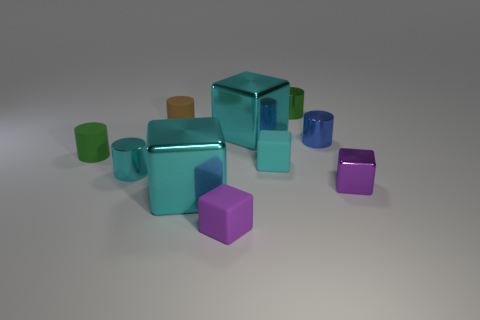Subtract all small rubber blocks. How many blocks are left? 3 Subtract all cyan cylinders. How many cylinders are left? 4 Subtract 4 cylinders. How many cylinders are left? 1 Add 3 small blue metal cylinders. How many small blue metal cylinders are left? 4 Add 8 green matte cylinders. How many green matte cylinders exist? 9 Subtract 0 green spheres. How many objects are left? 10 Subtract all gray cubes. Subtract all brown cylinders. How many cubes are left? 5 Subtract all purple balls. How many blue cubes are left? 0 Subtract all shiny objects. Subtract all small yellow matte cylinders. How many objects are left? 4 